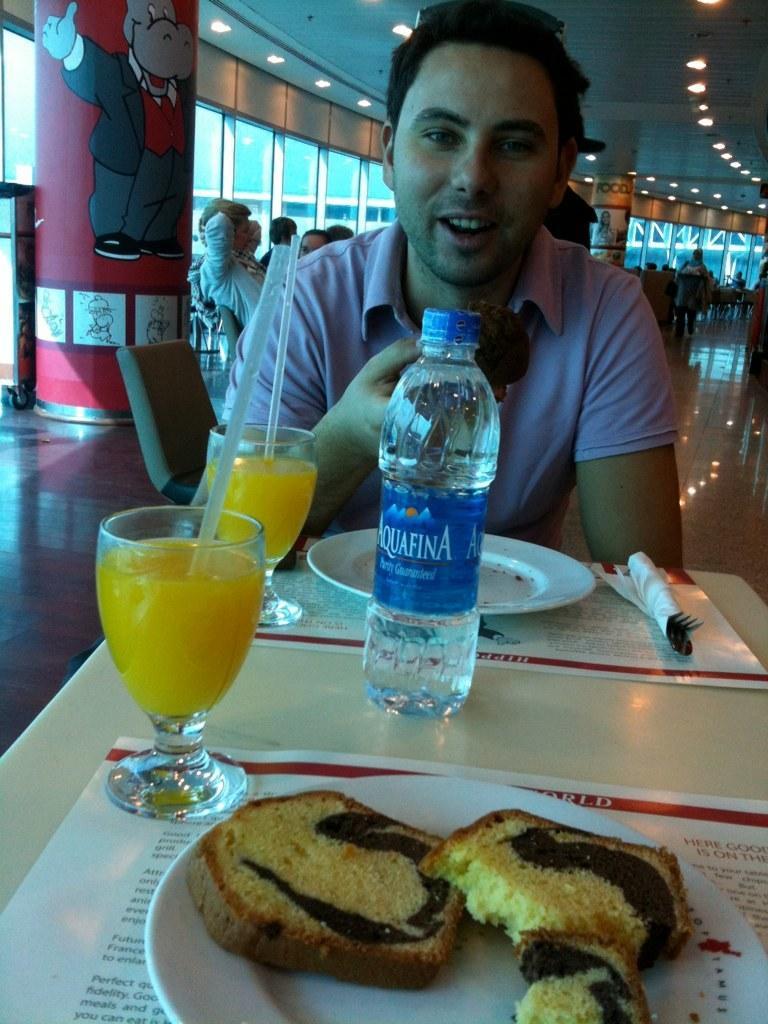Can you describe this image briefly? The person wearing pink shirt is eating something and there is a table in front of him which consists of a water bottle,juice and a bread and group of people behind him. 